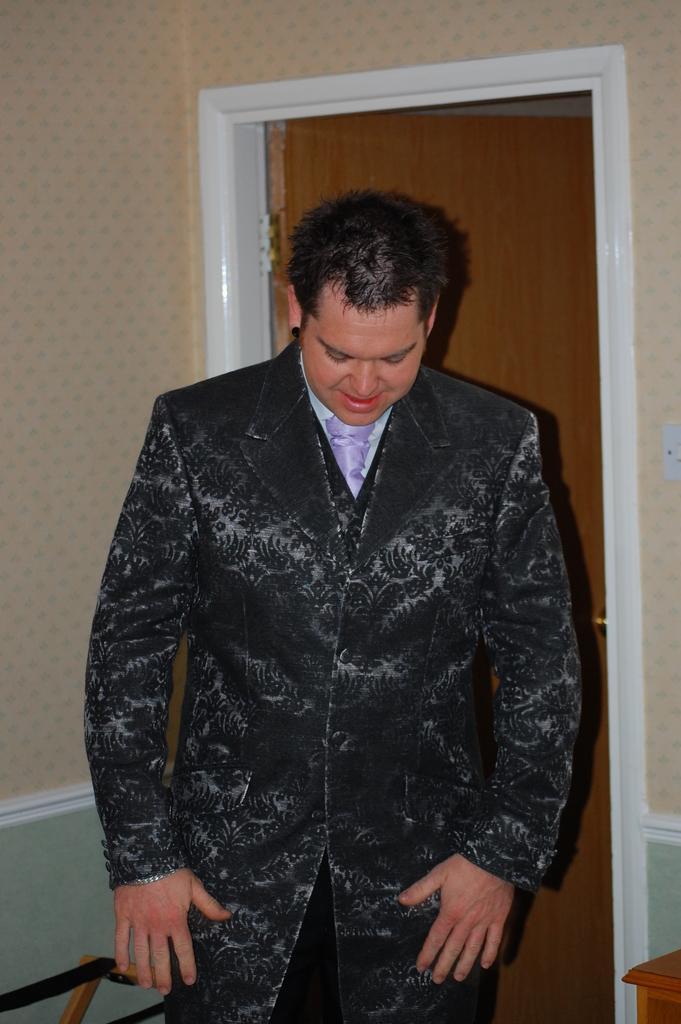Describe this image in one or two sentences. In this image we can see a man standing on the floor. In the background we can see walls and doors. 